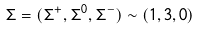<formula> <loc_0><loc_0><loc_500><loc_500>\Sigma = ( \Sigma ^ { + } , \Sigma ^ { 0 } , \Sigma ^ { - } ) \sim ( 1 , 3 , 0 )</formula> 